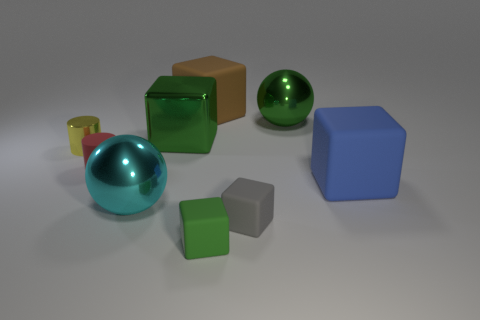What size is the blue cube that is made of the same material as the small green object?
Your response must be concise. Large. Do the green metal cube and the green metal ball have the same size?
Your answer should be very brief. Yes. Are there any small purple cylinders?
Your answer should be compact. No. What is the size of the rubber object that is the same color as the metallic cube?
Provide a short and direct response. Small. There is a shiny thing that is in front of the block that is on the right side of the ball on the right side of the big brown cube; how big is it?
Keep it short and to the point. Large. What number of small gray objects are made of the same material as the yellow cylinder?
Your answer should be very brief. 0. What number of other metallic things are the same size as the blue object?
Provide a short and direct response. 3. There is a cyan sphere on the right side of the tiny yellow shiny object that is to the left of the green object in front of the red rubber object; what is its material?
Make the answer very short. Metal. How many objects are either green blocks or matte cylinders?
Ensure brevity in your answer.  3. What is the shape of the small green matte thing?
Keep it short and to the point. Cube. 